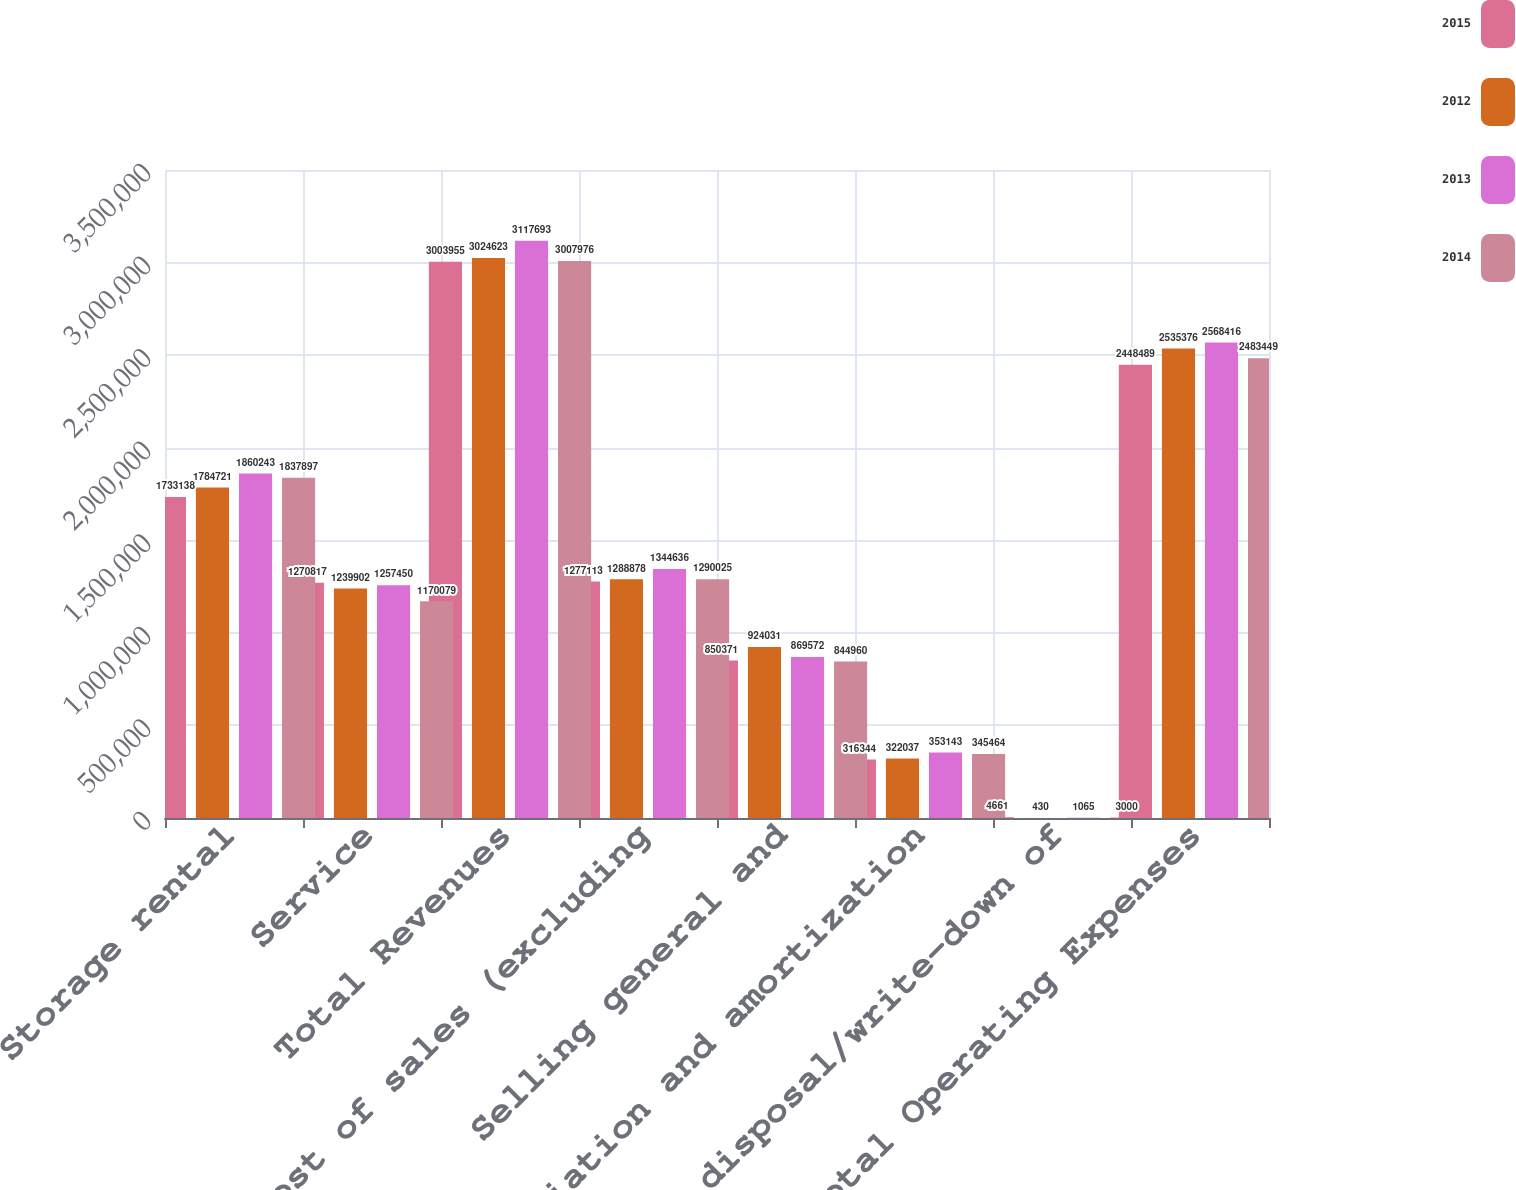Convert chart. <chart><loc_0><loc_0><loc_500><loc_500><stacked_bar_chart><ecel><fcel>Storage rental<fcel>Service<fcel>Total Revenues<fcel>Cost of sales (excluding<fcel>Selling general and<fcel>Depreciation and amortization<fcel>Loss on disposal/write-down of<fcel>Total Operating Expenses<nl><fcel>2015<fcel>1.73314e+06<fcel>1.27082e+06<fcel>3.00396e+06<fcel>1.27711e+06<fcel>850371<fcel>316344<fcel>4661<fcel>2.44849e+06<nl><fcel>2012<fcel>1.78472e+06<fcel>1.2399e+06<fcel>3.02462e+06<fcel>1.28888e+06<fcel>924031<fcel>322037<fcel>430<fcel>2.53538e+06<nl><fcel>2013<fcel>1.86024e+06<fcel>1.25745e+06<fcel>3.11769e+06<fcel>1.34464e+06<fcel>869572<fcel>353143<fcel>1065<fcel>2.56842e+06<nl><fcel>2014<fcel>1.8379e+06<fcel>1.17008e+06<fcel>3.00798e+06<fcel>1.29002e+06<fcel>844960<fcel>345464<fcel>3000<fcel>2.48345e+06<nl></chart> 